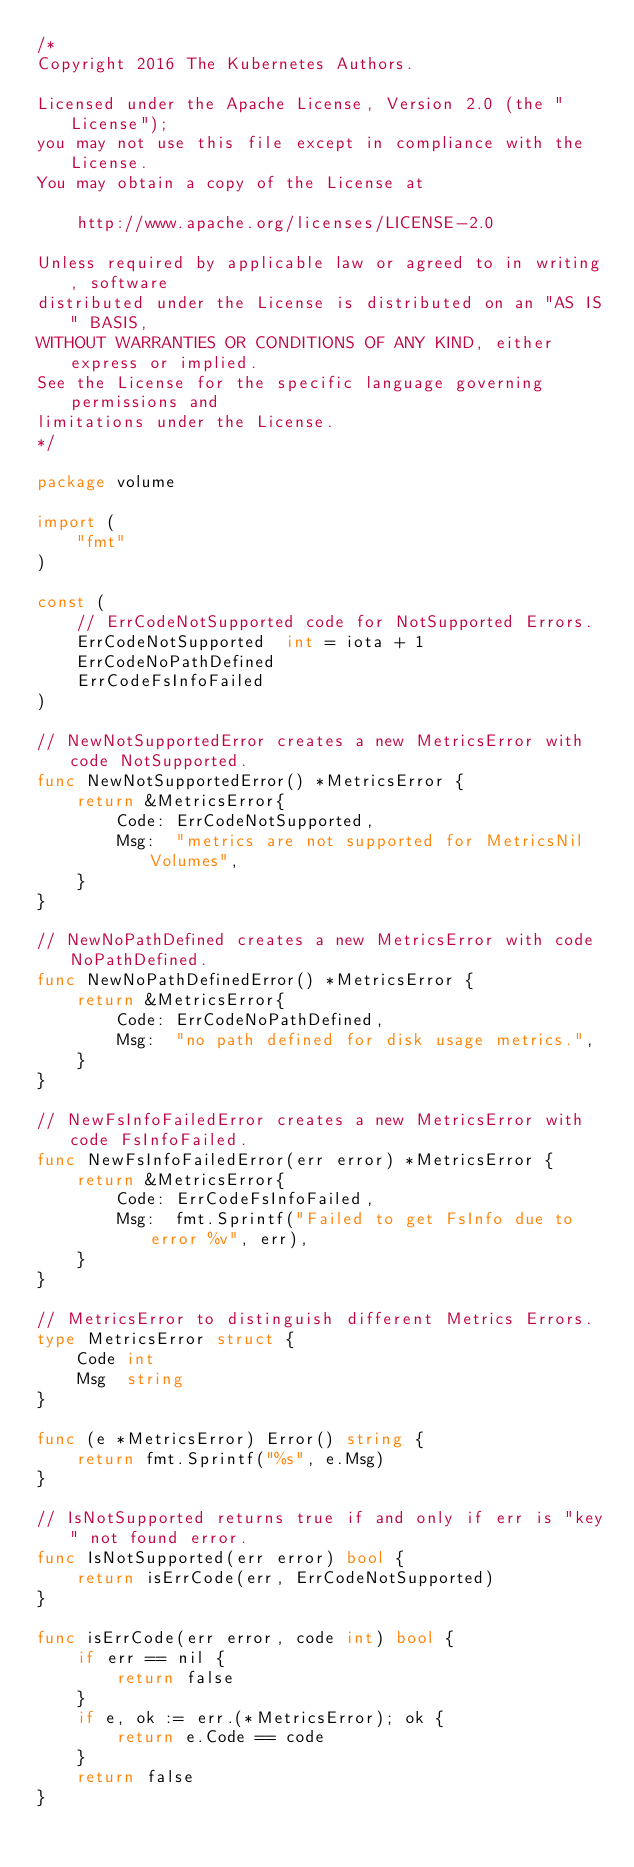<code> <loc_0><loc_0><loc_500><loc_500><_Go_>/*
Copyright 2016 The Kubernetes Authors.

Licensed under the Apache License, Version 2.0 (the "License");
you may not use this file except in compliance with the License.
You may obtain a copy of the License at

    http://www.apache.org/licenses/LICENSE-2.0

Unless required by applicable law or agreed to in writing, software
distributed under the License is distributed on an "AS IS" BASIS,
WITHOUT WARRANTIES OR CONDITIONS OF ANY KIND, either express or implied.
See the License for the specific language governing permissions and
limitations under the License.
*/

package volume

import (
	"fmt"
)

const (
	// ErrCodeNotSupported code for NotSupported Errors.
	ErrCodeNotSupported  int = iota + 1
	ErrCodeNoPathDefined
	ErrCodeFsInfoFailed
)

// NewNotSupportedError creates a new MetricsError with code NotSupported.
func NewNotSupportedError() *MetricsError {
	return &MetricsError{
		Code: ErrCodeNotSupported,
		Msg:  "metrics are not supported for MetricsNil Volumes",
	}
}

// NewNoPathDefined creates a new MetricsError with code NoPathDefined.
func NewNoPathDefinedError() *MetricsError {
	return &MetricsError{
		Code: ErrCodeNoPathDefined,
		Msg:  "no path defined for disk usage metrics.",
	}
}

// NewFsInfoFailedError creates a new MetricsError with code FsInfoFailed.
func NewFsInfoFailedError(err error) *MetricsError {
	return &MetricsError{
		Code: ErrCodeFsInfoFailed,
		Msg:  fmt.Sprintf("Failed to get FsInfo due to error %v", err),
	}
}

// MetricsError to distinguish different Metrics Errors.
type MetricsError struct {
	Code int
	Msg  string
}

func (e *MetricsError) Error() string {
	return fmt.Sprintf("%s", e.Msg)
}

// IsNotSupported returns true if and only if err is "key" not found error.
func IsNotSupported(err error) bool {
	return isErrCode(err, ErrCodeNotSupported)
}

func isErrCode(err error, code int) bool {
	if err == nil {
		return false
	}
	if e, ok := err.(*MetricsError); ok {
		return e.Code == code
	}
	return false
}
</code> 